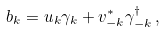<formula> <loc_0><loc_0><loc_500><loc_500>b _ { k } = u _ { k } \gamma _ { k } + v _ { - k } ^ { \ast } \gamma _ { - k } ^ { \dagger } \, ,</formula> 